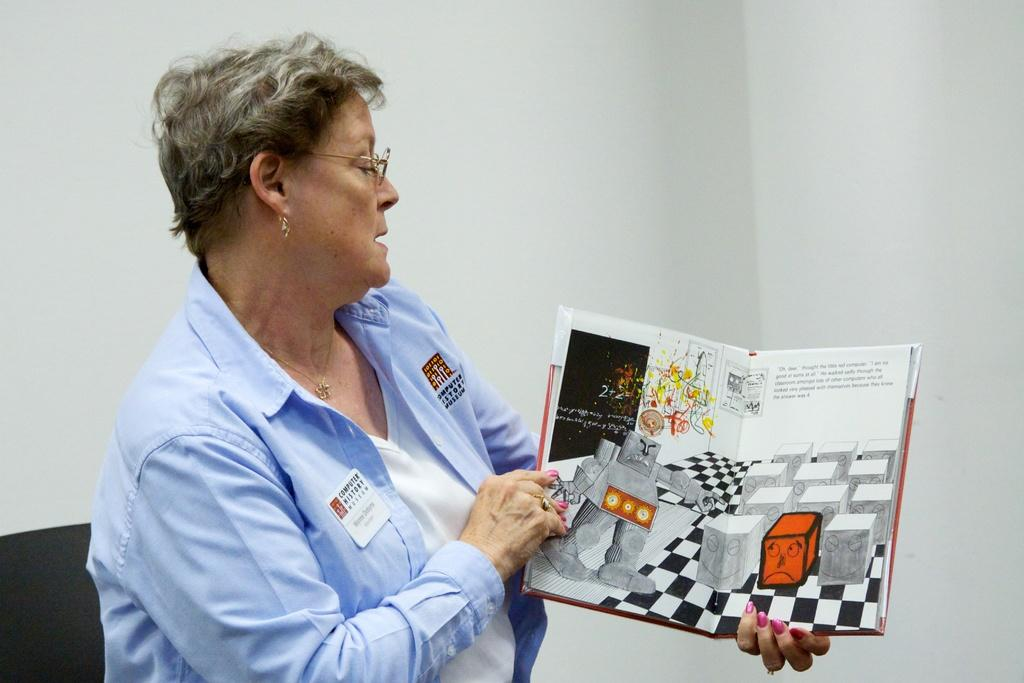Who is present in the image? There is a woman in the image. What is the woman holding in the image? The woman is holding a book. What type of content is in the book? The book contains text and images. What can be seen in the background of the image? There is a wall in the background of the image. What type of steel is used to construct the business in the image? There is no business or steel present in the image; it features a woman holding a book with a wall in the background. Is the woman standing in quicksand in the image? There is no quicksand present in the image; the woman is holding a book with a wall in the background. 